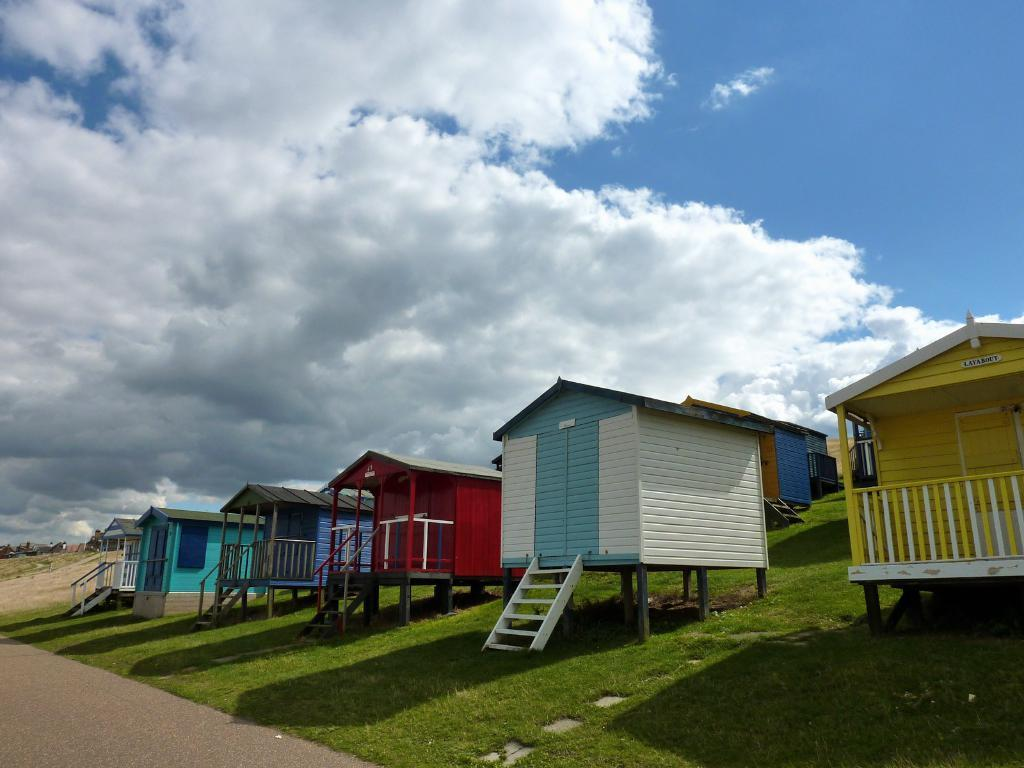What type of houses are in the image? There are wooden houses in the image. What is visible at the bottom of the image? There is grass visible at the bottom of the image. How would you describe the sky in the image? The sky is cloudy in the image. How many nerves can be seen in the image? There are no nerves visible in the image; it features wooden houses, grass, and a cloudy sky. 